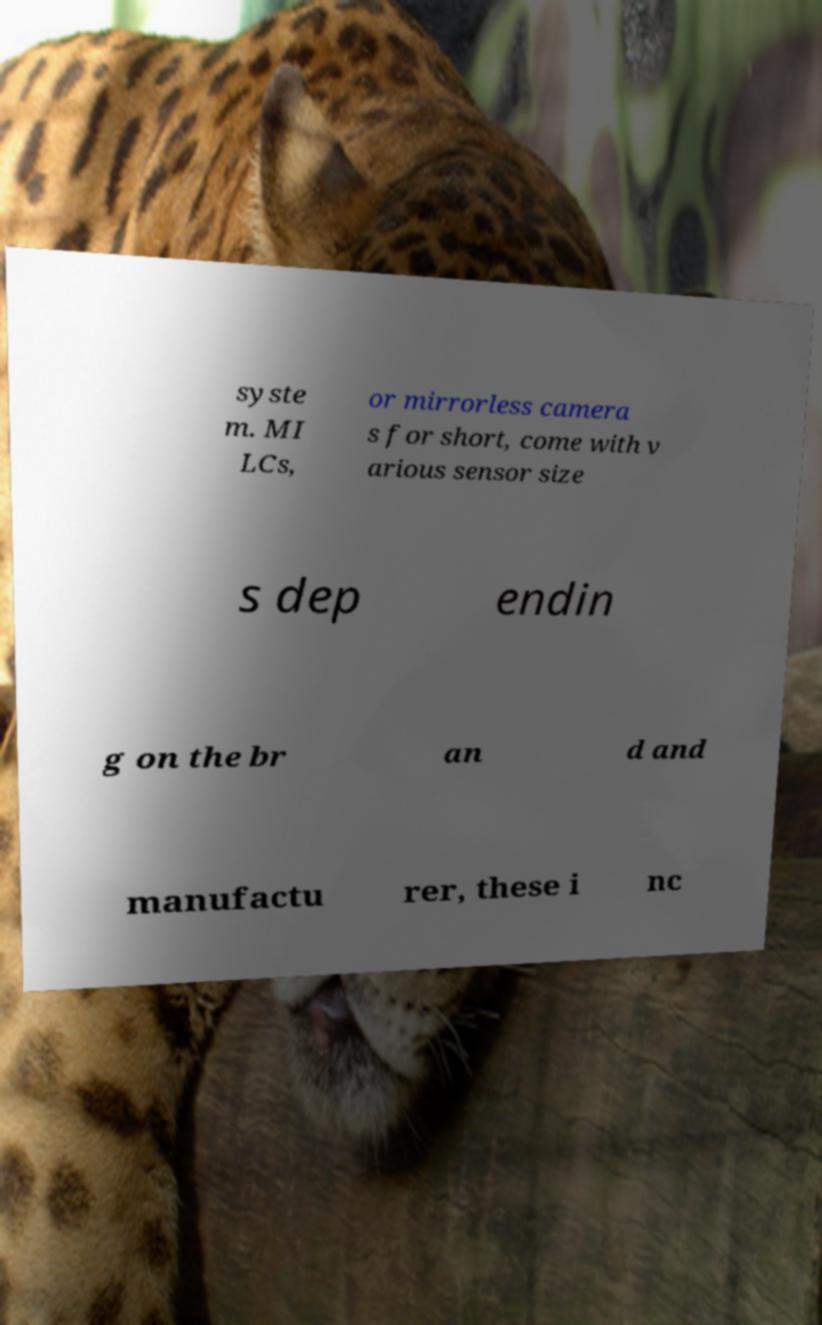Can you accurately transcribe the text from the provided image for me? syste m. MI LCs, or mirrorless camera s for short, come with v arious sensor size s dep endin g on the br an d and manufactu rer, these i nc 